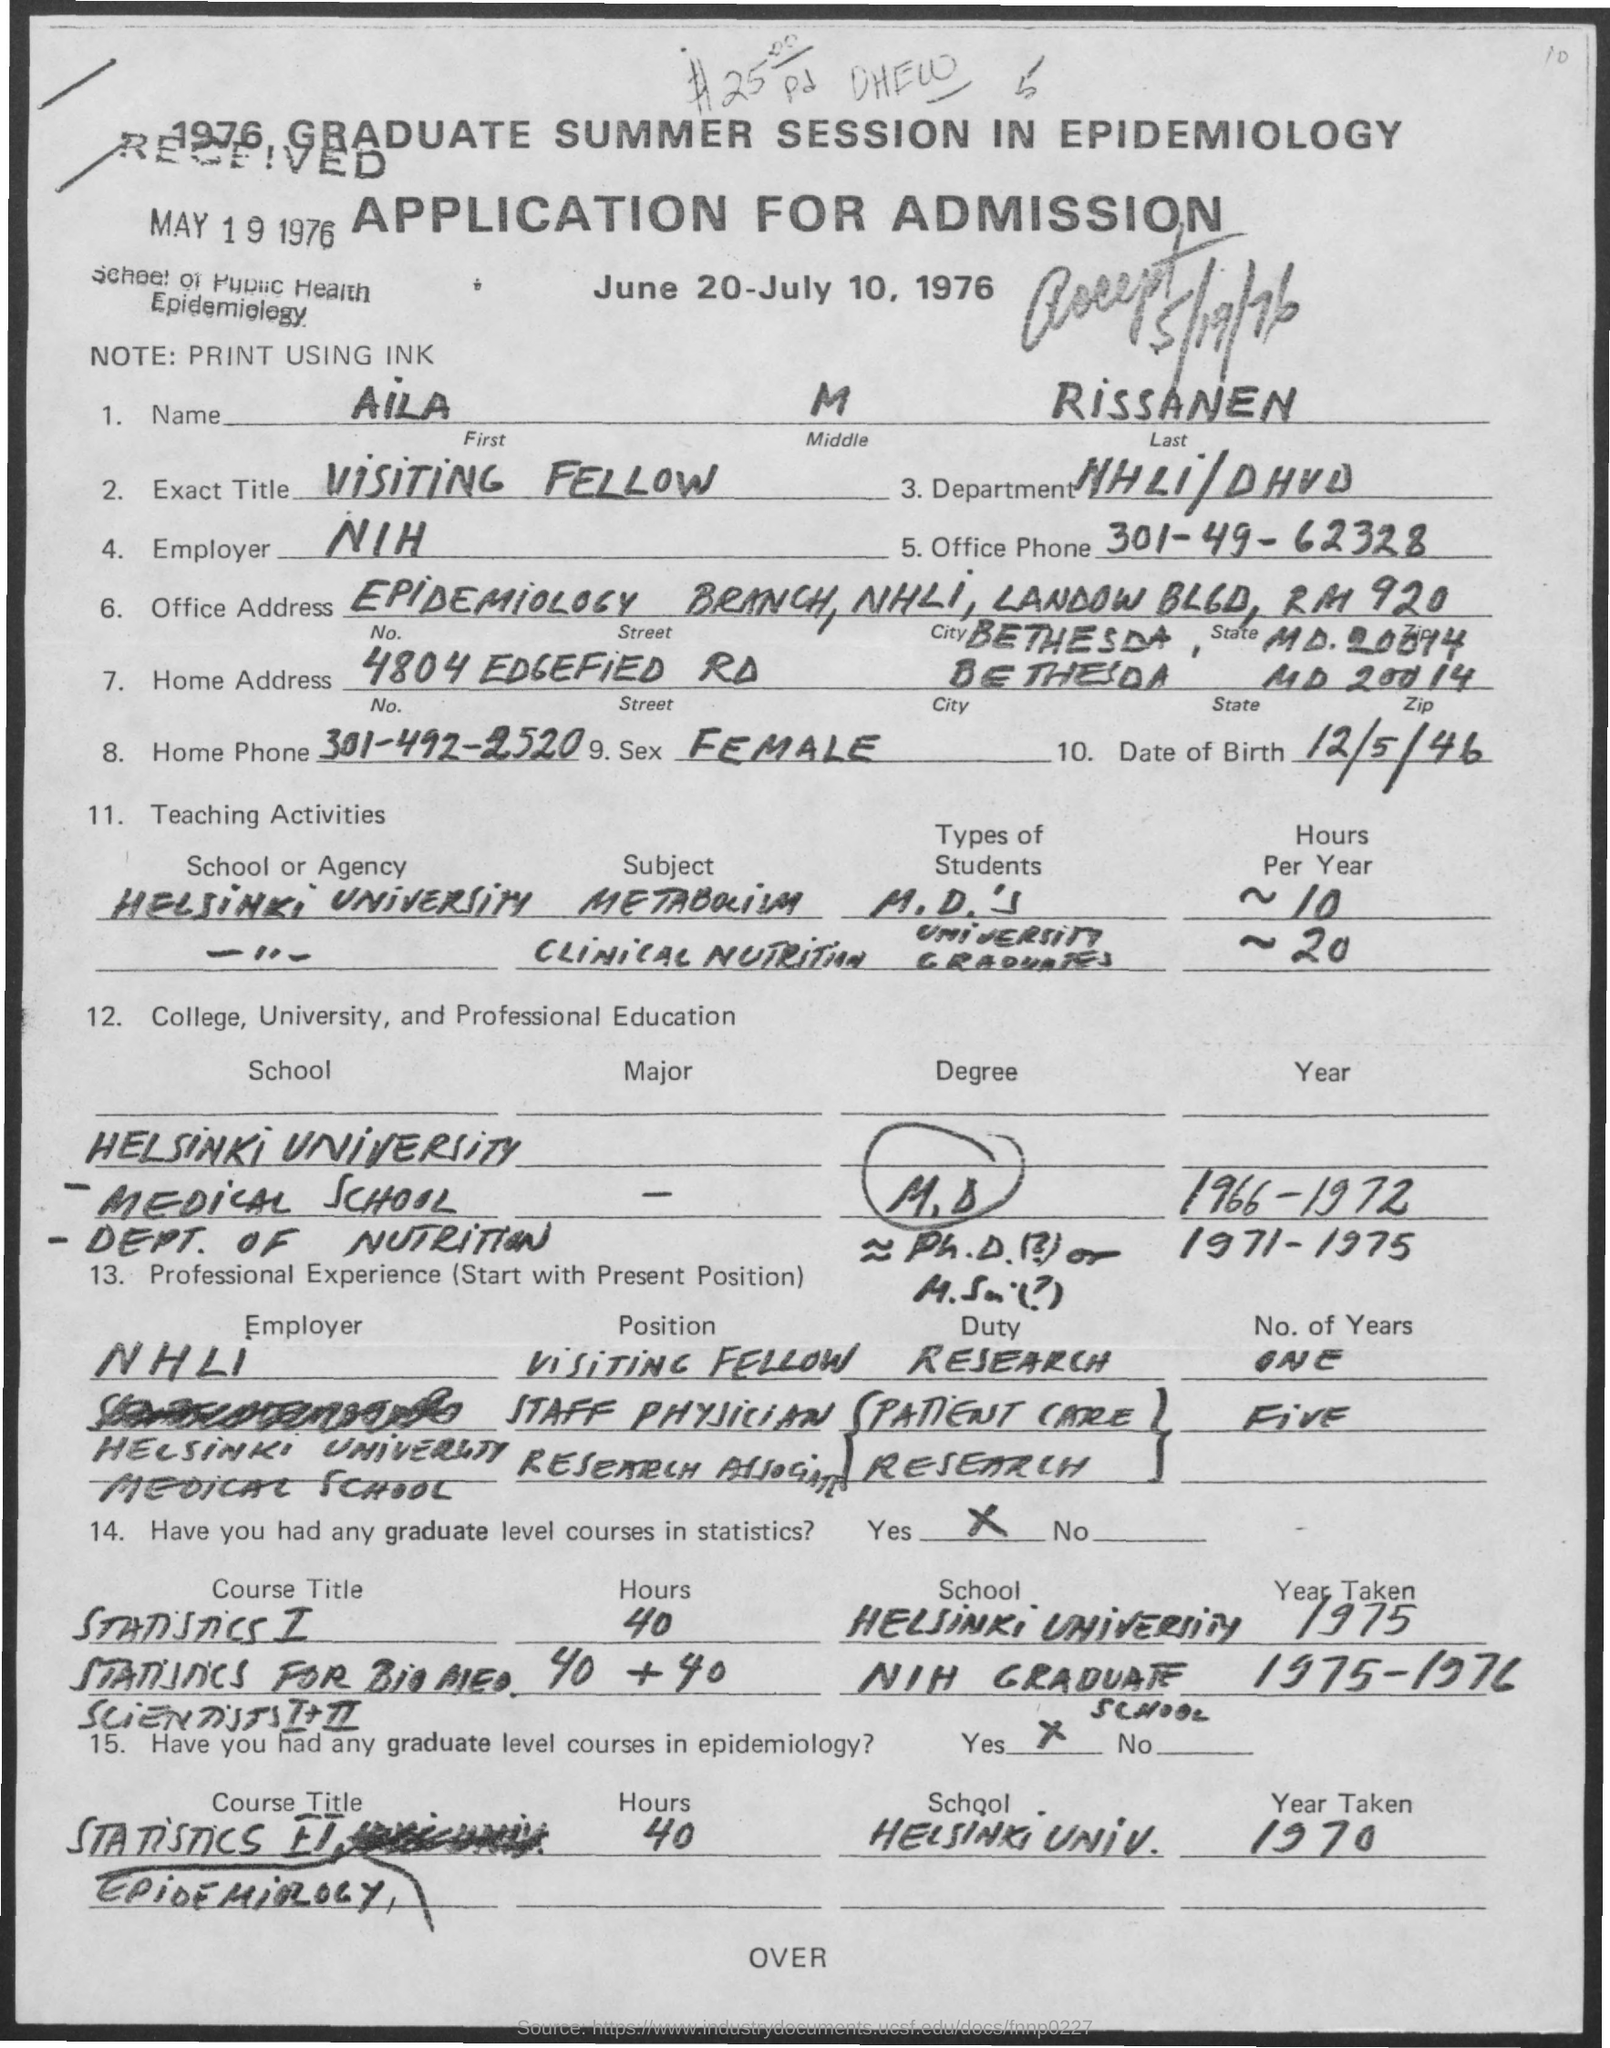Outline some significant characteristics in this image. The National Institutes of Health (NIH) is the employer of the worker in question. The first name is AILA. The last name is Rissanen. I have a middle name that begins with the letter M, but I am not at liberty to disclose it as it is a personal and confidential information. The City is Bethesda. 